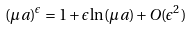Convert formula to latex. <formula><loc_0><loc_0><loc_500><loc_500>( \mu a ) ^ { \epsilon } = 1 + \epsilon \ln ( \mu a ) + O ( \epsilon ^ { 2 } )</formula> 